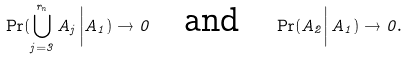<formula> <loc_0><loc_0><loc_500><loc_500>\Pr ( \bigcup _ { j = 3 } ^ { r _ { n } } A _ { j } \left | A _ { 1 } ) \to 0 \quad \text {and} \quad \Pr ( A _ { 2 } \right | A _ { 1 } ) \to 0 .</formula> 